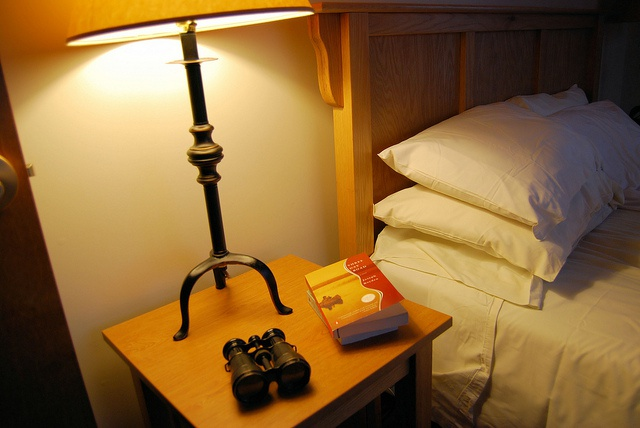Describe the objects in this image and their specific colors. I can see bed in brown, tan, olive, and gray tones, dining table in brown, orange, black, red, and maroon tones, book in brown, orange, red, and maroon tones, and book in brown, black, maroon, and orange tones in this image. 